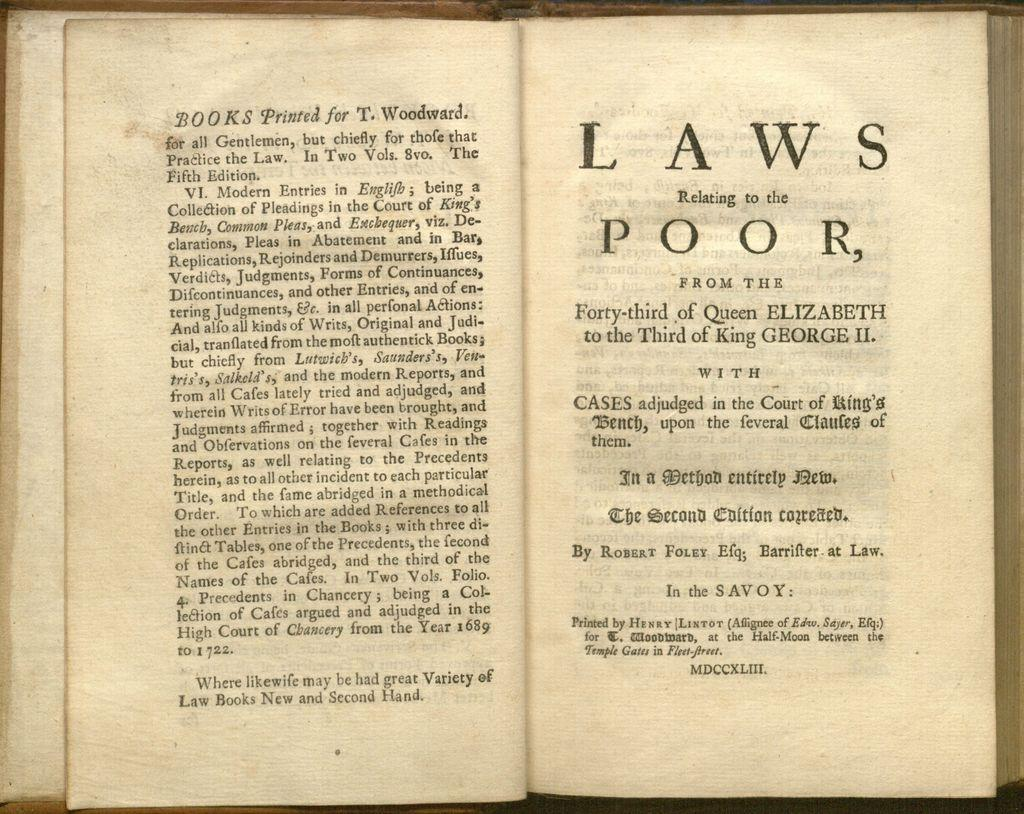Provide a one-sentence caption for the provided image. Book that is open about Laws from Queen Elizabeth. 